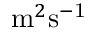Convert formula to latex. <formula><loc_0><loc_0><loc_500><loc_500>m ^ { 2 } s ^ { - 1 }</formula> 